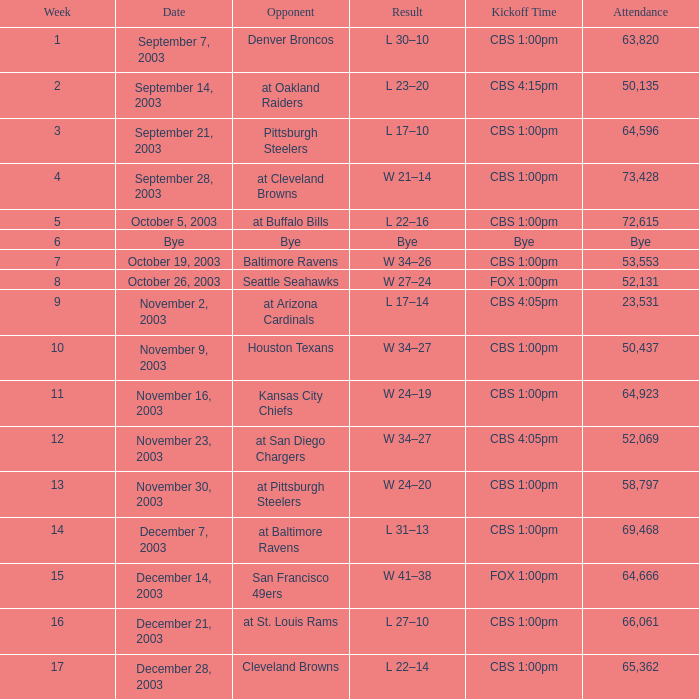What was the kickoff time on week 1? CBS 1:00pm. 